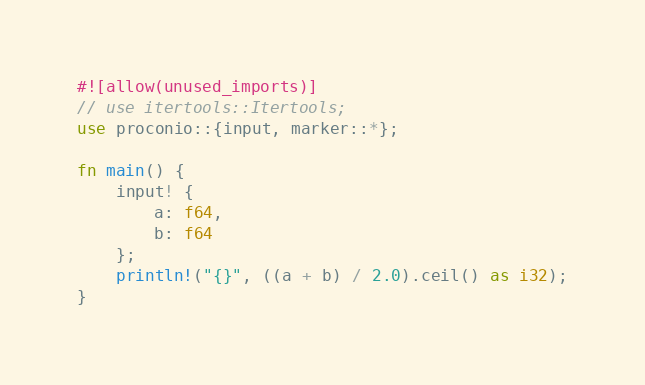Convert code to text. <code><loc_0><loc_0><loc_500><loc_500><_Rust_>#![allow(unused_imports)]
// use itertools::Itertools;
use proconio::{input, marker::*};

fn main() {
    input! {
        a: f64,
        b: f64
    };
    println!("{}", ((a + b) / 2.0).ceil() as i32);
}
</code> 